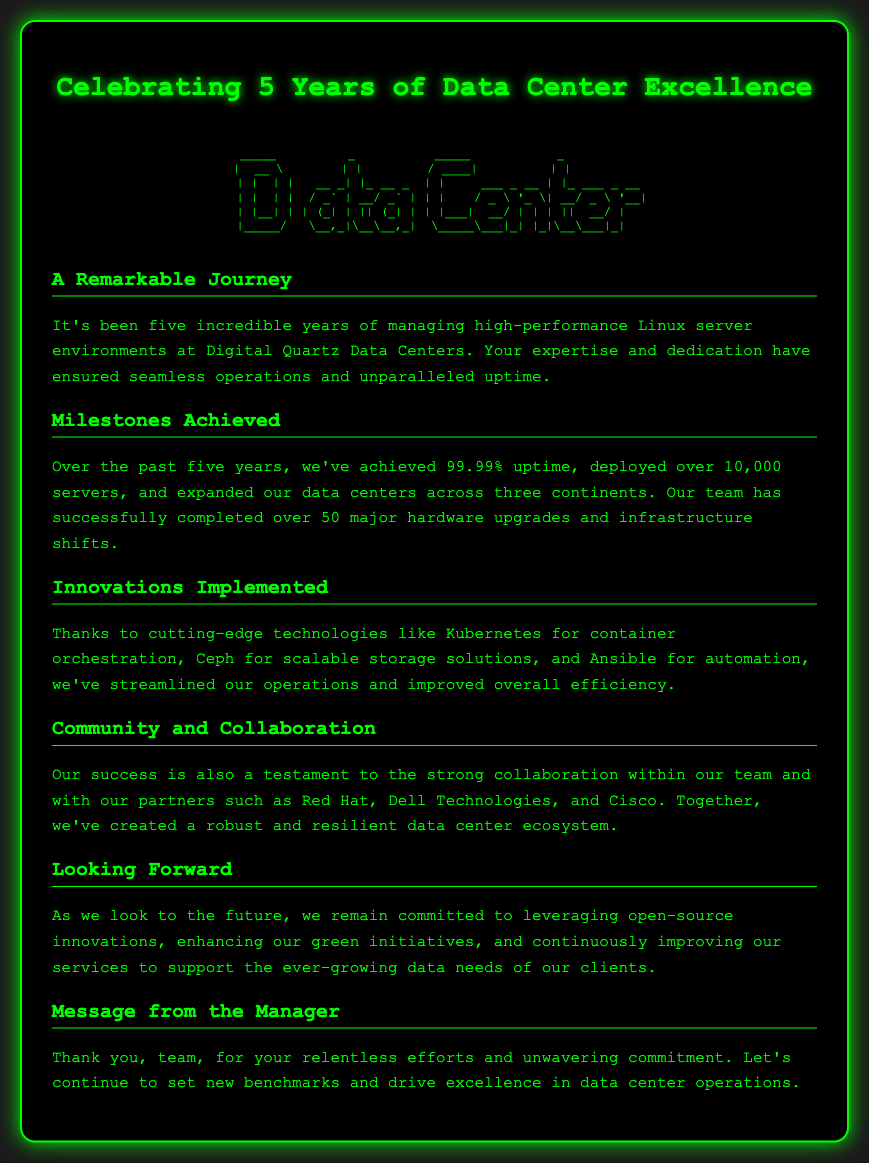What is the title of the card? The title of the card is presented prominently at the top and reads "Celebrating 5 Years of Data Center Excellence."
Answer: Celebrating 5 Years of Data Center Excellence How many servers have been deployed in five years? The document specifies that over 10,000 servers have been deployed over the past five years.
Answer: 10,000 What is the uptime achievement over the five years? The uptime achievement mentioned in the document is stated as 99.99%.
Answer: 99.99% Which technologies were highlighted for streamlining operations? The document lists Kubernetes, Ceph, and Ansible as the cutting-edge technologies implemented for operations improvement.
Answer: Kubernetes, Ceph, Ansible What is the focus for future commitments mentioned? Future commitments include leveraging open-source innovations and enhancing green initiatives to support data needs.
Answer: open-source innovations, green initiatives How many major hardware upgrades were completed? The document states that over 50 major hardware upgrades have been successfully completed.
Answer: 50 Who are some of the partners mentioned in collaboration? The document names Red Hat, Dell Technologies, and Cisco as partners in collaboration.
Answer: Red Hat, Dell Technologies, Cisco What message did the manager convey to the team? The manager expressed gratitude for the team's efforts and a commitment to continue achieving excellence in data center operations.
Answer: Thank you, team 